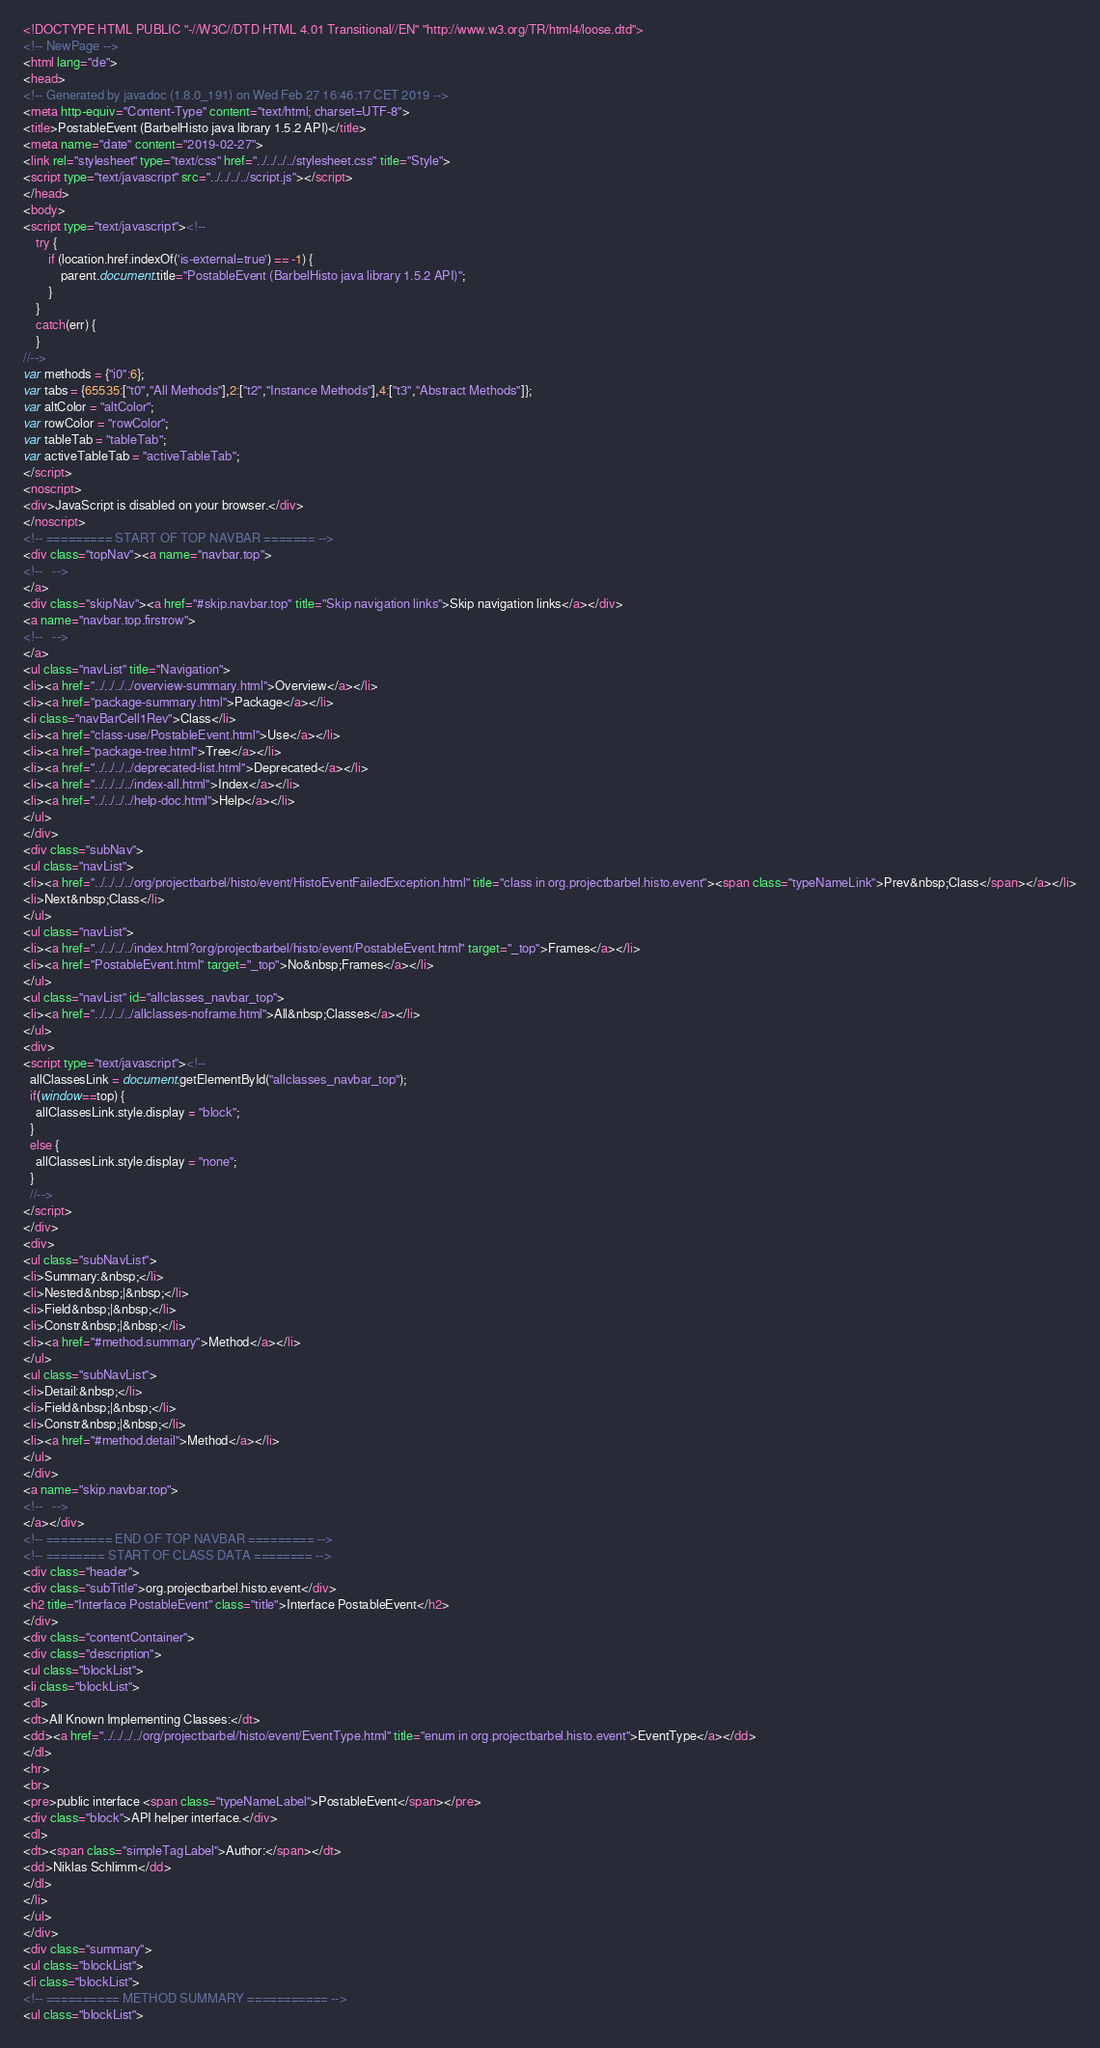<code> <loc_0><loc_0><loc_500><loc_500><_HTML_><!DOCTYPE HTML PUBLIC "-//W3C//DTD HTML 4.01 Transitional//EN" "http://www.w3.org/TR/html4/loose.dtd">
<!-- NewPage -->
<html lang="de">
<head>
<!-- Generated by javadoc (1.8.0_191) on Wed Feb 27 16:46:17 CET 2019 -->
<meta http-equiv="Content-Type" content="text/html; charset=UTF-8">
<title>PostableEvent (BarbelHisto java library 1.5.2 API)</title>
<meta name="date" content="2019-02-27">
<link rel="stylesheet" type="text/css" href="../../../../stylesheet.css" title="Style">
<script type="text/javascript" src="../../../../script.js"></script>
</head>
<body>
<script type="text/javascript"><!--
    try {
        if (location.href.indexOf('is-external=true') == -1) {
            parent.document.title="PostableEvent (BarbelHisto java library 1.5.2 API)";
        }
    }
    catch(err) {
    }
//-->
var methods = {"i0":6};
var tabs = {65535:["t0","All Methods"],2:["t2","Instance Methods"],4:["t3","Abstract Methods"]};
var altColor = "altColor";
var rowColor = "rowColor";
var tableTab = "tableTab";
var activeTableTab = "activeTableTab";
</script>
<noscript>
<div>JavaScript is disabled on your browser.</div>
</noscript>
<!-- ========= START OF TOP NAVBAR ======= -->
<div class="topNav"><a name="navbar.top">
<!--   -->
</a>
<div class="skipNav"><a href="#skip.navbar.top" title="Skip navigation links">Skip navigation links</a></div>
<a name="navbar.top.firstrow">
<!--   -->
</a>
<ul class="navList" title="Navigation">
<li><a href="../../../../overview-summary.html">Overview</a></li>
<li><a href="package-summary.html">Package</a></li>
<li class="navBarCell1Rev">Class</li>
<li><a href="class-use/PostableEvent.html">Use</a></li>
<li><a href="package-tree.html">Tree</a></li>
<li><a href="../../../../deprecated-list.html">Deprecated</a></li>
<li><a href="../../../../index-all.html">Index</a></li>
<li><a href="../../../../help-doc.html">Help</a></li>
</ul>
</div>
<div class="subNav">
<ul class="navList">
<li><a href="../../../../org/projectbarbel/histo/event/HistoEventFailedException.html" title="class in org.projectbarbel.histo.event"><span class="typeNameLink">Prev&nbsp;Class</span></a></li>
<li>Next&nbsp;Class</li>
</ul>
<ul class="navList">
<li><a href="../../../../index.html?org/projectbarbel/histo/event/PostableEvent.html" target="_top">Frames</a></li>
<li><a href="PostableEvent.html" target="_top">No&nbsp;Frames</a></li>
</ul>
<ul class="navList" id="allclasses_navbar_top">
<li><a href="../../../../allclasses-noframe.html">All&nbsp;Classes</a></li>
</ul>
<div>
<script type="text/javascript"><!--
  allClassesLink = document.getElementById("allclasses_navbar_top");
  if(window==top) {
    allClassesLink.style.display = "block";
  }
  else {
    allClassesLink.style.display = "none";
  }
  //-->
</script>
</div>
<div>
<ul class="subNavList">
<li>Summary:&nbsp;</li>
<li>Nested&nbsp;|&nbsp;</li>
<li>Field&nbsp;|&nbsp;</li>
<li>Constr&nbsp;|&nbsp;</li>
<li><a href="#method.summary">Method</a></li>
</ul>
<ul class="subNavList">
<li>Detail:&nbsp;</li>
<li>Field&nbsp;|&nbsp;</li>
<li>Constr&nbsp;|&nbsp;</li>
<li><a href="#method.detail">Method</a></li>
</ul>
</div>
<a name="skip.navbar.top">
<!--   -->
</a></div>
<!-- ========= END OF TOP NAVBAR ========= -->
<!-- ======== START OF CLASS DATA ======== -->
<div class="header">
<div class="subTitle">org.projectbarbel.histo.event</div>
<h2 title="Interface PostableEvent" class="title">Interface PostableEvent</h2>
</div>
<div class="contentContainer">
<div class="description">
<ul class="blockList">
<li class="blockList">
<dl>
<dt>All Known Implementing Classes:</dt>
<dd><a href="../../../../org/projectbarbel/histo/event/EventType.html" title="enum in org.projectbarbel.histo.event">EventType</a></dd>
</dl>
<hr>
<br>
<pre>public interface <span class="typeNameLabel">PostableEvent</span></pre>
<div class="block">API helper interface.</div>
<dl>
<dt><span class="simpleTagLabel">Author:</span></dt>
<dd>Niklas Schlimm</dd>
</dl>
</li>
</ul>
</div>
<div class="summary">
<ul class="blockList">
<li class="blockList">
<!-- ========== METHOD SUMMARY =========== -->
<ul class="blockList"></code> 